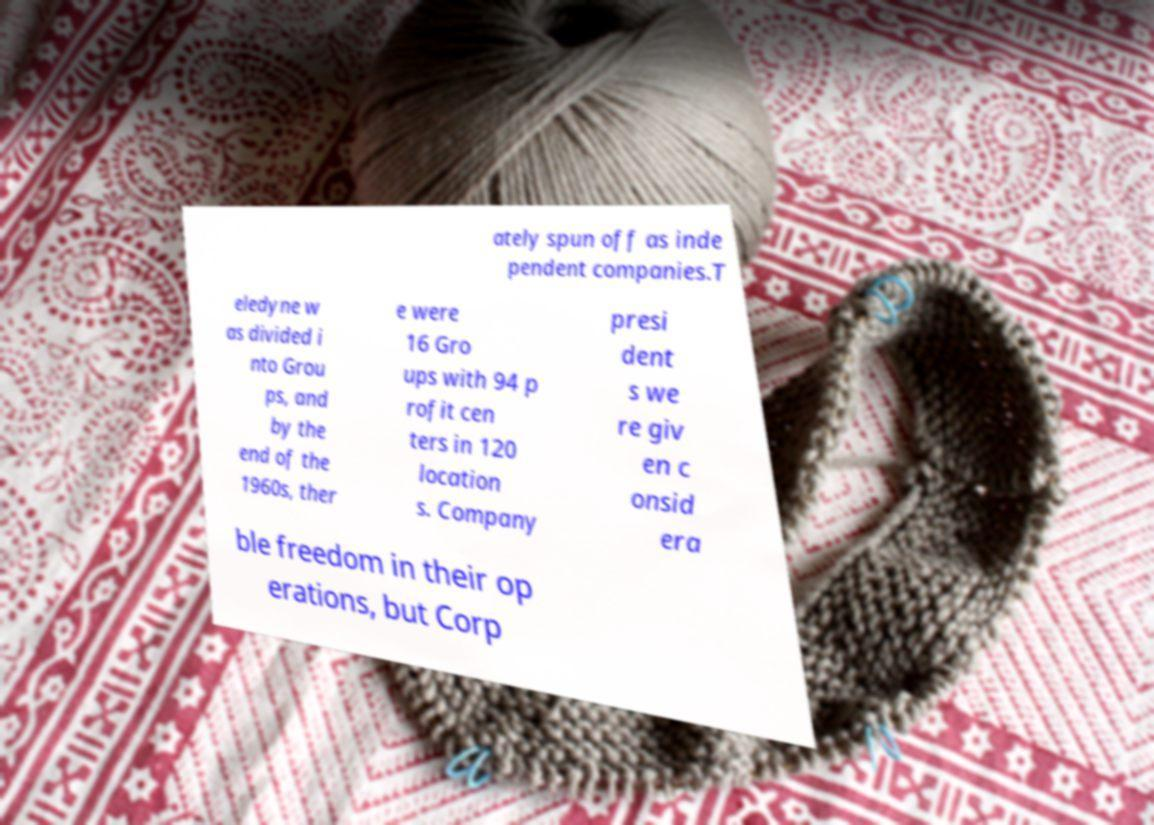Could you assist in decoding the text presented in this image and type it out clearly? ately spun off as inde pendent companies.T eledyne w as divided i nto Grou ps, and by the end of the 1960s, ther e were 16 Gro ups with 94 p rofit cen ters in 120 location s. Company presi dent s we re giv en c onsid era ble freedom in their op erations, but Corp 